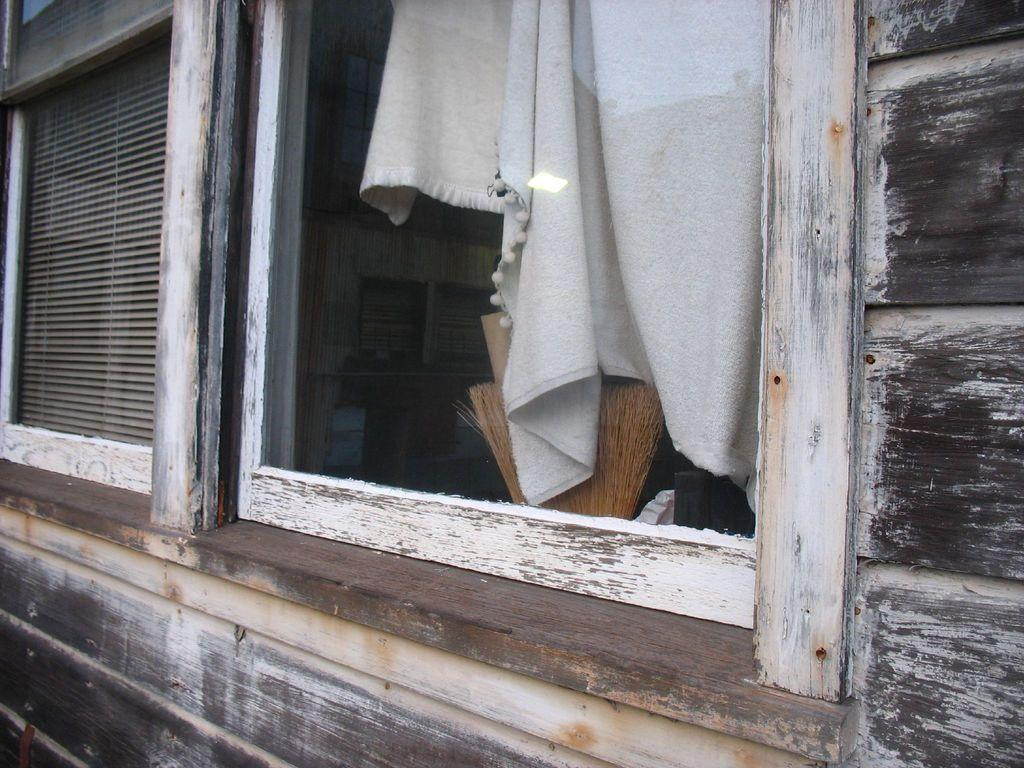What type of wall is visible in the image? There is a wooden wall in the image. What can be seen on the wooden wall? There are windows in the image. What is covering the windows? There is a curtain in the image. What cleaning tool is present in the room? There is a broomstick in the image. What type of view does the image provide? The image provides an inside view of a room. What other objects can be seen in the room? Various objects are present in the room. What type of songs can be heard coming from the pet in the image? There is no pet present in the image, and therefore no songs can be heard. 